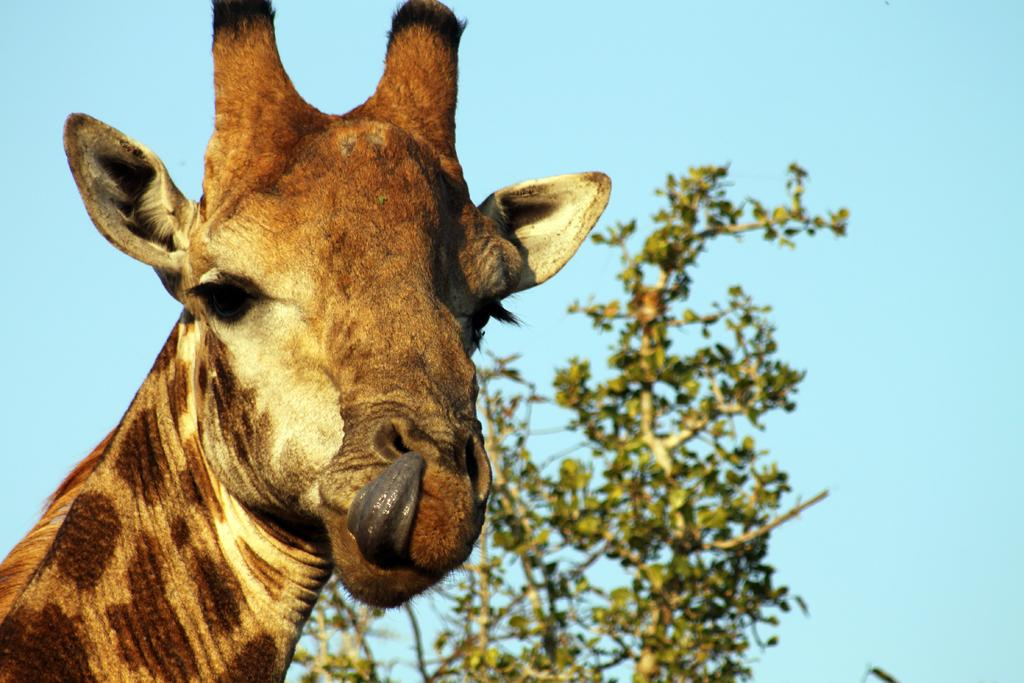What animal is the main subject of the image? There is a giraffe in the image. What can be seen in the background of the image? There are trees and the sky visible in the background of the image. Can you tell me the color of the snail in the image? There is no snail present in the image, so its color cannot be determined. 